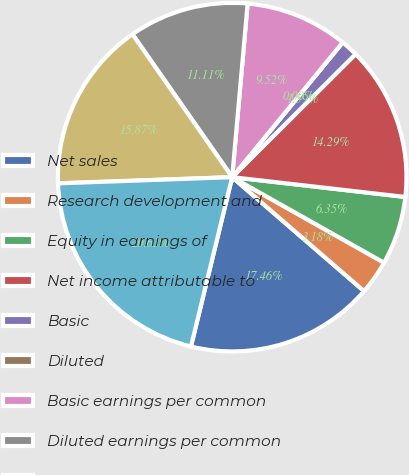<chart> <loc_0><loc_0><loc_500><loc_500><pie_chart><fcel>Net sales<fcel>Research development and<fcel>Equity in earnings of<fcel>Net income attributable to<fcel>Basic<fcel>Diluted<fcel>Basic earnings per common<fcel>Diluted earnings per common<fcel>Working capital<fcel>Total assets<nl><fcel>17.46%<fcel>3.18%<fcel>6.35%<fcel>14.29%<fcel>1.59%<fcel>0.0%<fcel>9.52%<fcel>11.11%<fcel>15.87%<fcel>20.63%<nl></chart> 